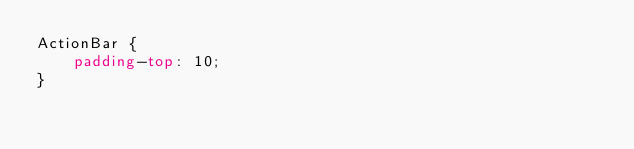<code> <loc_0><loc_0><loc_500><loc_500><_CSS_>ActionBar {
    padding-top: 10;
}</code> 